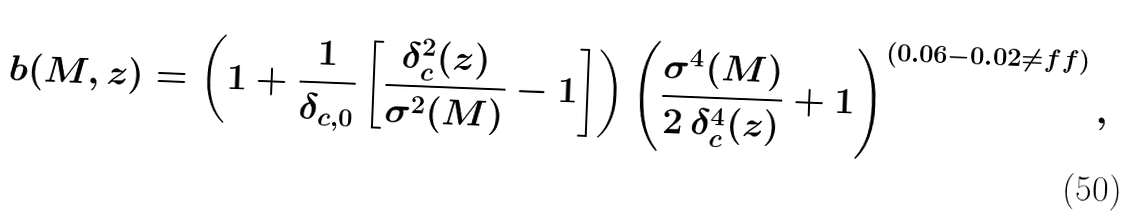<formula> <loc_0><loc_0><loc_500><loc_500>b ( M , z ) = \left ( 1 + \frac { 1 } { \delta _ { c , 0 } } \left [ \frac { \delta _ { c } ^ { 2 } ( z ) } { \sigma ^ { 2 } ( M ) } - 1 \right ] \right ) \left ( \frac { \sigma ^ { 4 } ( M ) } { 2 \, \delta _ { c } ^ { 4 } ( z ) } + 1 \right ) ^ { ( 0 . 0 6 - 0 . 0 2 \ne f f ) } ,</formula> 